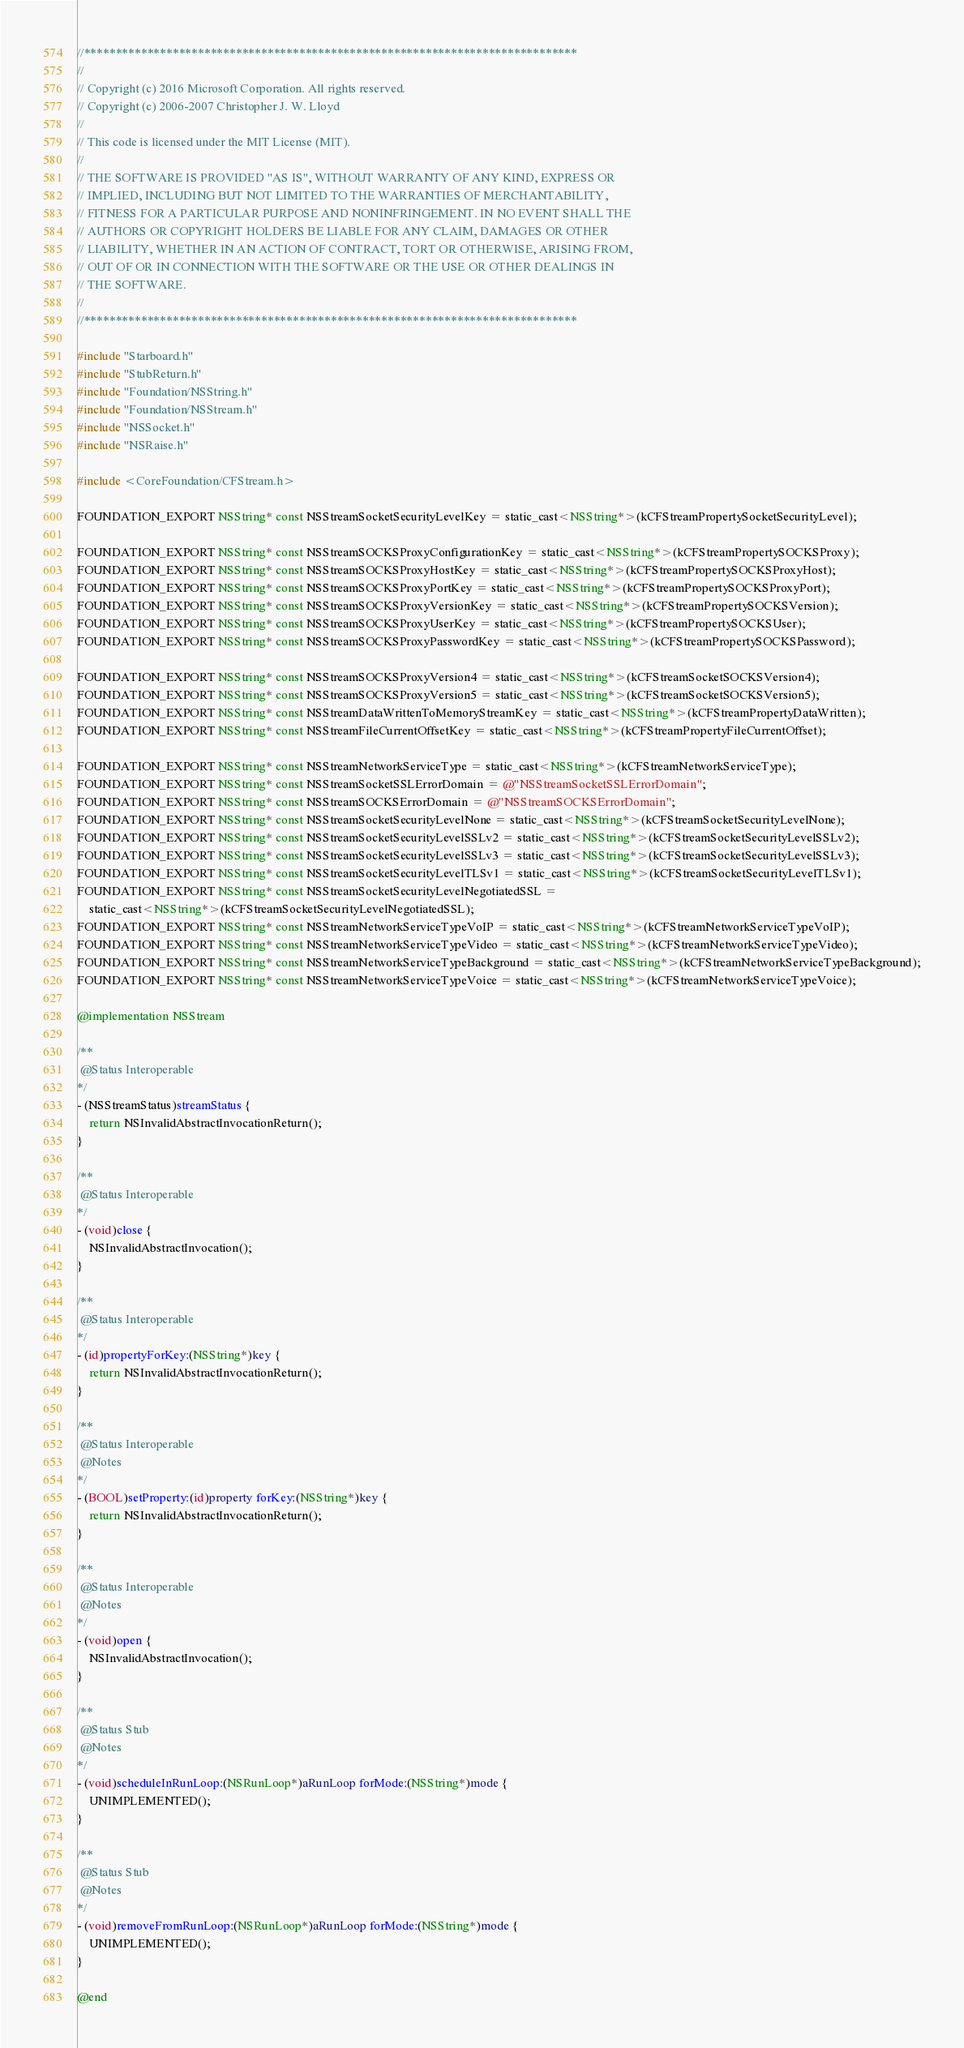Convert code to text. <code><loc_0><loc_0><loc_500><loc_500><_ObjectiveC_>//******************************************************************************
//
// Copyright (c) 2016 Microsoft Corporation. All rights reserved.
// Copyright (c) 2006-2007 Christopher J. W. Lloyd
//
// This code is licensed under the MIT License (MIT).
//
// THE SOFTWARE IS PROVIDED "AS IS", WITHOUT WARRANTY OF ANY KIND, EXPRESS OR
// IMPLIED, INCLUDING BUT NOT LIMITED TO THE WARRANTIES OF MERCHANTABILITY,
// FITNESS FOR A PARTICULAR PURPOSE AND NONINFRINGEMENT. IN NO EVENT SHALL THE
// AUTHORS OR COPYRIGHT HOLDERS BE LIABLE FOR ANY CLAIM, DAMAGES OR OTHER
// LIABILITY, WHETHER IN AN ACTION OF CONTRACT, TORT OR OTHERWISE, ARISING FROM,
// OUT OF OR IN CONNECTION WITH THE SOFTWARE OR THE USE OR OTHER DEALINGS IN
// THE SOFTWARE.
//
//******************************************************************************

#include "Starboard.h"
#include "StubReturn.h"
#include "Foundation/NSString.h"
#include "Foundation/NSStream.h"
#include "NSSocket.h"
#include "NSRaise.h"

#include <CoreFoundation/CFStream.h>

FOUNDATION_EXPORT NSString* const NSStreamSocketSecurityLevelKey = static_cast<NSString*>(kCFStreamPropertySocketSecurityLevel);

FOUNDATION_EXPORT NSString* const NSStreamSOCKSProxyConfigurationKey = static_cast<NSString*>(kCFStreamPropertySOCKSProxy);
FOUNDATION_EXPORT NSString* const NSStreamSOCKSProxyHostKey = static_cast<NSString*>(kCFStreamPropertySOCKSProxyHost);
FOUNDATION_EXPORT NSString* const NSStreamSOCKSProxyPortKey = static_cast<NSString*>(kCFStreamPropertySOCKSProxyPort);
FOUNDATION_EXPORT NSString* const NSStreamSOCKSProxyVersionKey = static_cast<NSString*>(kCFStreamPropertySOCKSVersion);
FOUNDATION_EXPORT NSString* const NSStreamSOCKSProxyUserKey = static_cast<NSString*>(kCFStreamPropertySOCKSUser);
FOUNDATION_EXPORT NSString* const NSStreamSOCKSProxyPasswordKey = static_cast<NSString*>(kCFStreamPropertySOCKSPassword);

FOUNDATION_EXPORT NSString* const NSStreamSOCKSProxyVersion4 = static_cast<NSString*>(kCFStreamSocketSOCKSVersion4);
FOUNDATION_EXPORT NSString* const NSStreamSOCKSProxyVersion5 = static_cast<NSString*>(kCFStreamSocketSOCKSVersion5);
FOUNDATION_EXPORT NSString* const NSStreamDataWrittenToMemoryStreamKey = static_cast<NSString*>(kCFStreamPropertyDataWritten);
FOUNDATION_EXPORT NSString* const NSStreamFileCurrentOffsetKey = static_cast<NSString*>(kCFStreamPropertyFileCurrentOffset);

FOUNDATION_EXPORT NSString* const NSStreamNetworkServiceType = static_cast<NSString*>(kCFStreamNetworkServiceType);
FOUNDATION_EXPORT NSString* const NSStreamSocketSSLErrorDomain = @"NSStreamSocketSSLErrorDomain";
FOUNDATION_EXPORT NSString* const NSStreamSOCKSErrorDomain = @"NSStreamSOCKSErrorDomain";
FOUNDATION_EXPORT NSString* const NSStreamSocketSecurityLevelNone = static_cast<NSString*>(kCFStreamSocketSecurityLevelNone);
FOUNDATION_EXPORT NSString* const NSStreamSocketSecurityLevelSSLv2 = static_cast<NSString*>(kCFStreamSocketSecurityLevelSSLv2);
FOUNDATION_EXPORT NSString* const NSStreamSocketSecurityLevelSSLv3 = static_cast<NSString*>(kCFStreamSocketSecurityLevelSSLv3);
FOUNDATION_EXPORT NSString* const NSStreamSocketSecurityLevelTLSv1 = static_cast<NSString*>(kCFStreamSocketSecurityLevelTLSv1);
FOUNDATION_EXPORT NSString* const NSStreamSocketSecurityLevelNegotiatedSSL =
    static_cast<NSString*>(kCFStreamSocketSecurityLevelNegotiatedSSL);
FOUNDATION_EXPORT NSString* const NSStreamNetworkServiceTypeVoIP = static_cast<NSString*>(kCFStreamNetworkServiceTypeVoIP);
FOUNDATION_EXPORT NSString* const NSStreamNetworkServiceTypeVideo = static_cast<NSString*>(kCFStreamNetworkServiceTypeVideo);
FOUNDATION_EXPORT NSString* const NSStreamNetworkServiceTypeBackground = static_cast<NSString*>(kCFStreamNetworkServiceTypeBackground);
FOUNDATION_EXPORT NSString* const NSStreamNetworkServiceTypeVoice = static_cast<NSString*>(kCFStreamNetworkServiceTypeVoice);

@implementation NSStream

/**
 @Status Interoperable
*/
- (NSStreamStatus)streamStatus {
    return NSInvalidAbstractInvocationReturn();
}

/**
 @Status Interoperable
*/
- (void)close {
    NSInvalidAbstractInvocation();
}

/**
 @Status Interoperable
*/
- (id)propertyForKey:(NSString*)key {
    return NSInvalidAbstractInvocationReturn();
}

/**
 @Status Interoperable
 @Notes
*/
- (BOOL)setProperty:(id)property forKey:(NSString*)key {
    return NSInvalidAbstractInvocationReturn();
}

/**
 @Status Interoperable
 @Notes
*/
- (void)open {
    NSInvalidAbstractInvocation();
}

/**
 @Status Stub
 @Notes
*/
- (void)scheduleInRunLoop:(NSRunLoop*)aRunLoop forMode:(NSString*)mode {
    UNIMPLEMENTED();
}

/**
 @Status Stub
 @Notes
*/
- (void)removeFromRunLoop:(NSRunLoop*)aRunLoop forMode:(NSString*)mode {
    UNIMPLEMENTED();
}

@end
</code> 